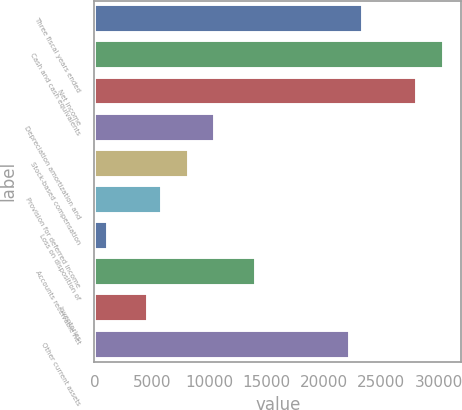Convert chart to OTSL. <chart><loc_0><loc_0><loc_500><loc_500><bar_chart><fcel>Three fiscal years ended<fcel>Cash and cash equivalents<fcel>Net income<fcel>Depreciation amortization and<fcel>Stock-based compensation<fcel>Provision for deferred income<fcel>Loss on disposition of<fcel>Accounts receivable net<fcel>Inventories<fcel>Other current assets<nl><fcel>23435<fcel>30464.6<fcel>28121.4<fcel>10547.4<fcel>8204.2<fcel>5861<fcel>1174.6<fcel>14062.2<fcel>4689.4<fcel>22263.4<nl></chart> 